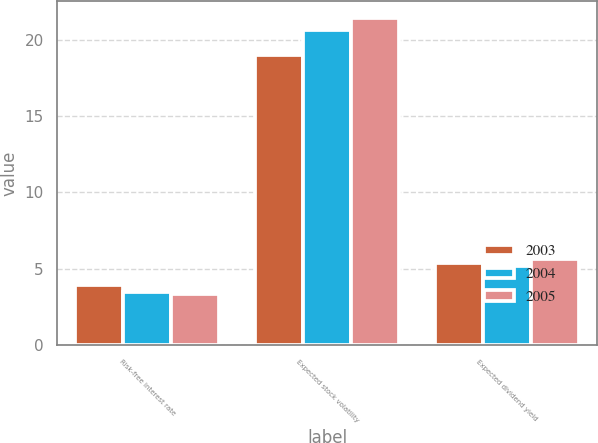Convert chart. <chart><loc_0><loc_0><loc_500><loc_500><stacked_bar_chart><ecel><fcel>Risk-free interest rate<fcel>Expected stock volatility<fcel>Expected dividend yield<nl><fcel>2003<fcel>3.95<fcel>19<fcel>5.37<nl><fcel>2004<fcel>3.47<fcel>20.63<fcel>5.16<nl><fcel>2005<fcel>3.35<fcel>21.44<fcel>5.66<nl></chart> 